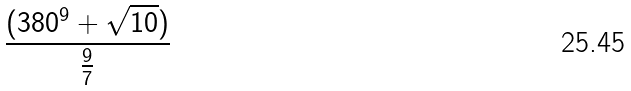<formula> <loc_0><loc_0><loc_500><loc_500>\frac { ( 3 8 0 ^ { 9 } + \sqrt { 1 0 } ) } { \frac { 9 } { 7 } }</formula> 